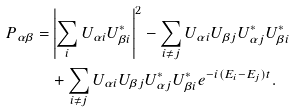<formula> <loc_0><loc_0><loc_500><loc_500>P _ { \alpha \beta } = & \left | \sum _ { i } U _ { \alpha i } U _ { \beta i } ^ { * } \right | ^ { 2 } - \sum _ { i \neq j } U _ { \alpha i } U _ { \beta j } U _ { \alpha j } ^ { * } U _ { \beta i } ^ { * } \\ & + \sum _ { i \neq j } U _ { \alpha i } U _ { \beta j } U _ { \alpha j } ^ { * } U _ { \beta i } ^ { * } e ^ { - i ( E _ { i } - E _ { j } ) t } .</formula> 